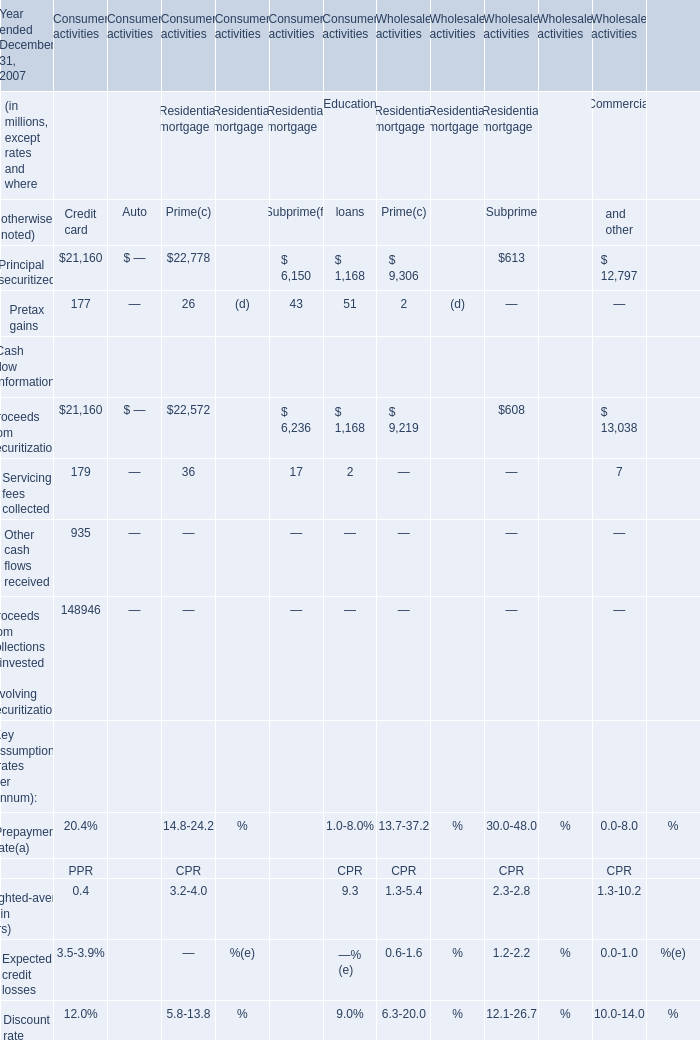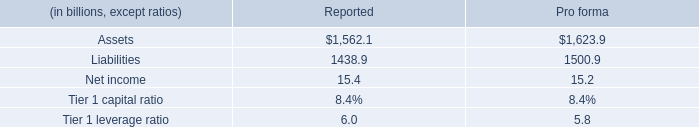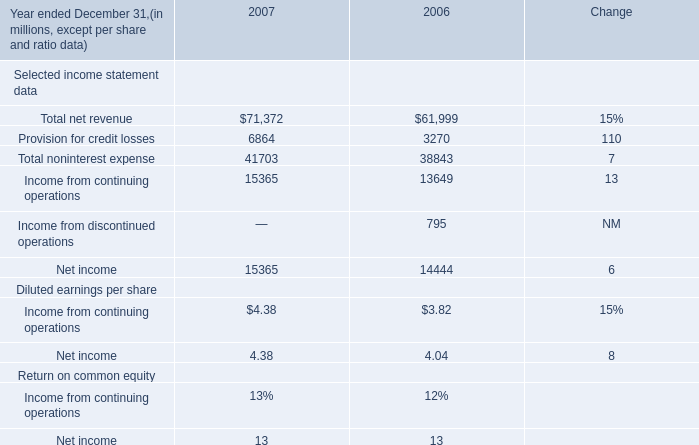What is the average amount of Net income of 2006, and Assets of Pro forma ? 
Computations: ((14444.0 + 1623.9) / 2)
Answer: 8033.95. 